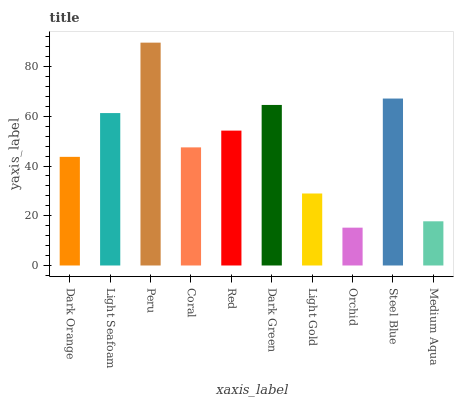Is Orchid the minimum?
Answer yes or no. Yes. Is Peru the maximum?
Answer yes or no. Yes. Is Light Seafoam the minimum?
Answer yes or no. No. Is Light Seafoam the maximum?
Answer yes or no. No. Is Light Seafoam greater than Dark Orange?
Answer yes or no. Yes. Is Dark Orange less than Light Seafoam?
Answer yes or no. Yes. Is Dark Orange greater than Light Seafoam?
Answer yes or no. No. Is Light Seafoam less than Dark Orange?
Answer yes or no. No. Is Red the high median?
Answer yes or no. Yes. Is Coral the low median?
Answer yes or no. Yes. Is Peru the high median?
Answer yes or no. No. Is Dark Orange the low median?
Answer yes or no. No. 